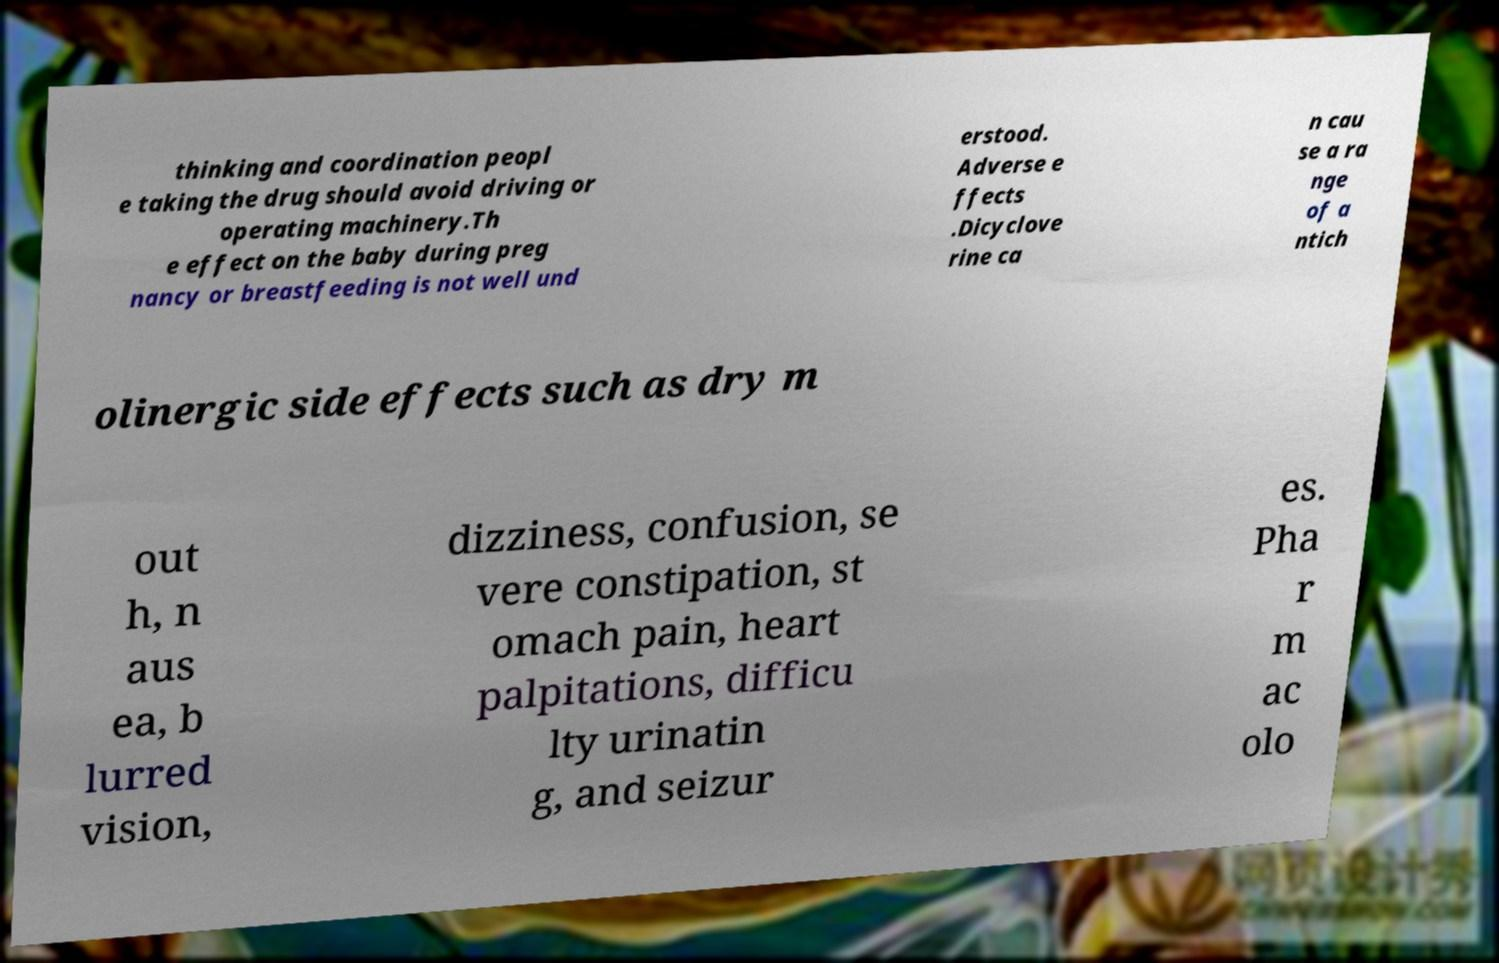Can you accurately transcribe the text from the provided image for me? thinking and coordination peopl e taking the drug should avoid driving or operating machinery.Th e effect on the baby during preg nancy or breastfeeding is not well und erstood. Adverse e ffects .Dicyclove rine ca n cau se a ra nge of a ntich olinergic side effects such as dry m out h, n aus ea, b lurred vision, dizziness, confusion, se vere constipation, st omach pain, heart palpitations, difficu lty urinatin g, and seizur es. Pha r m ac olo 